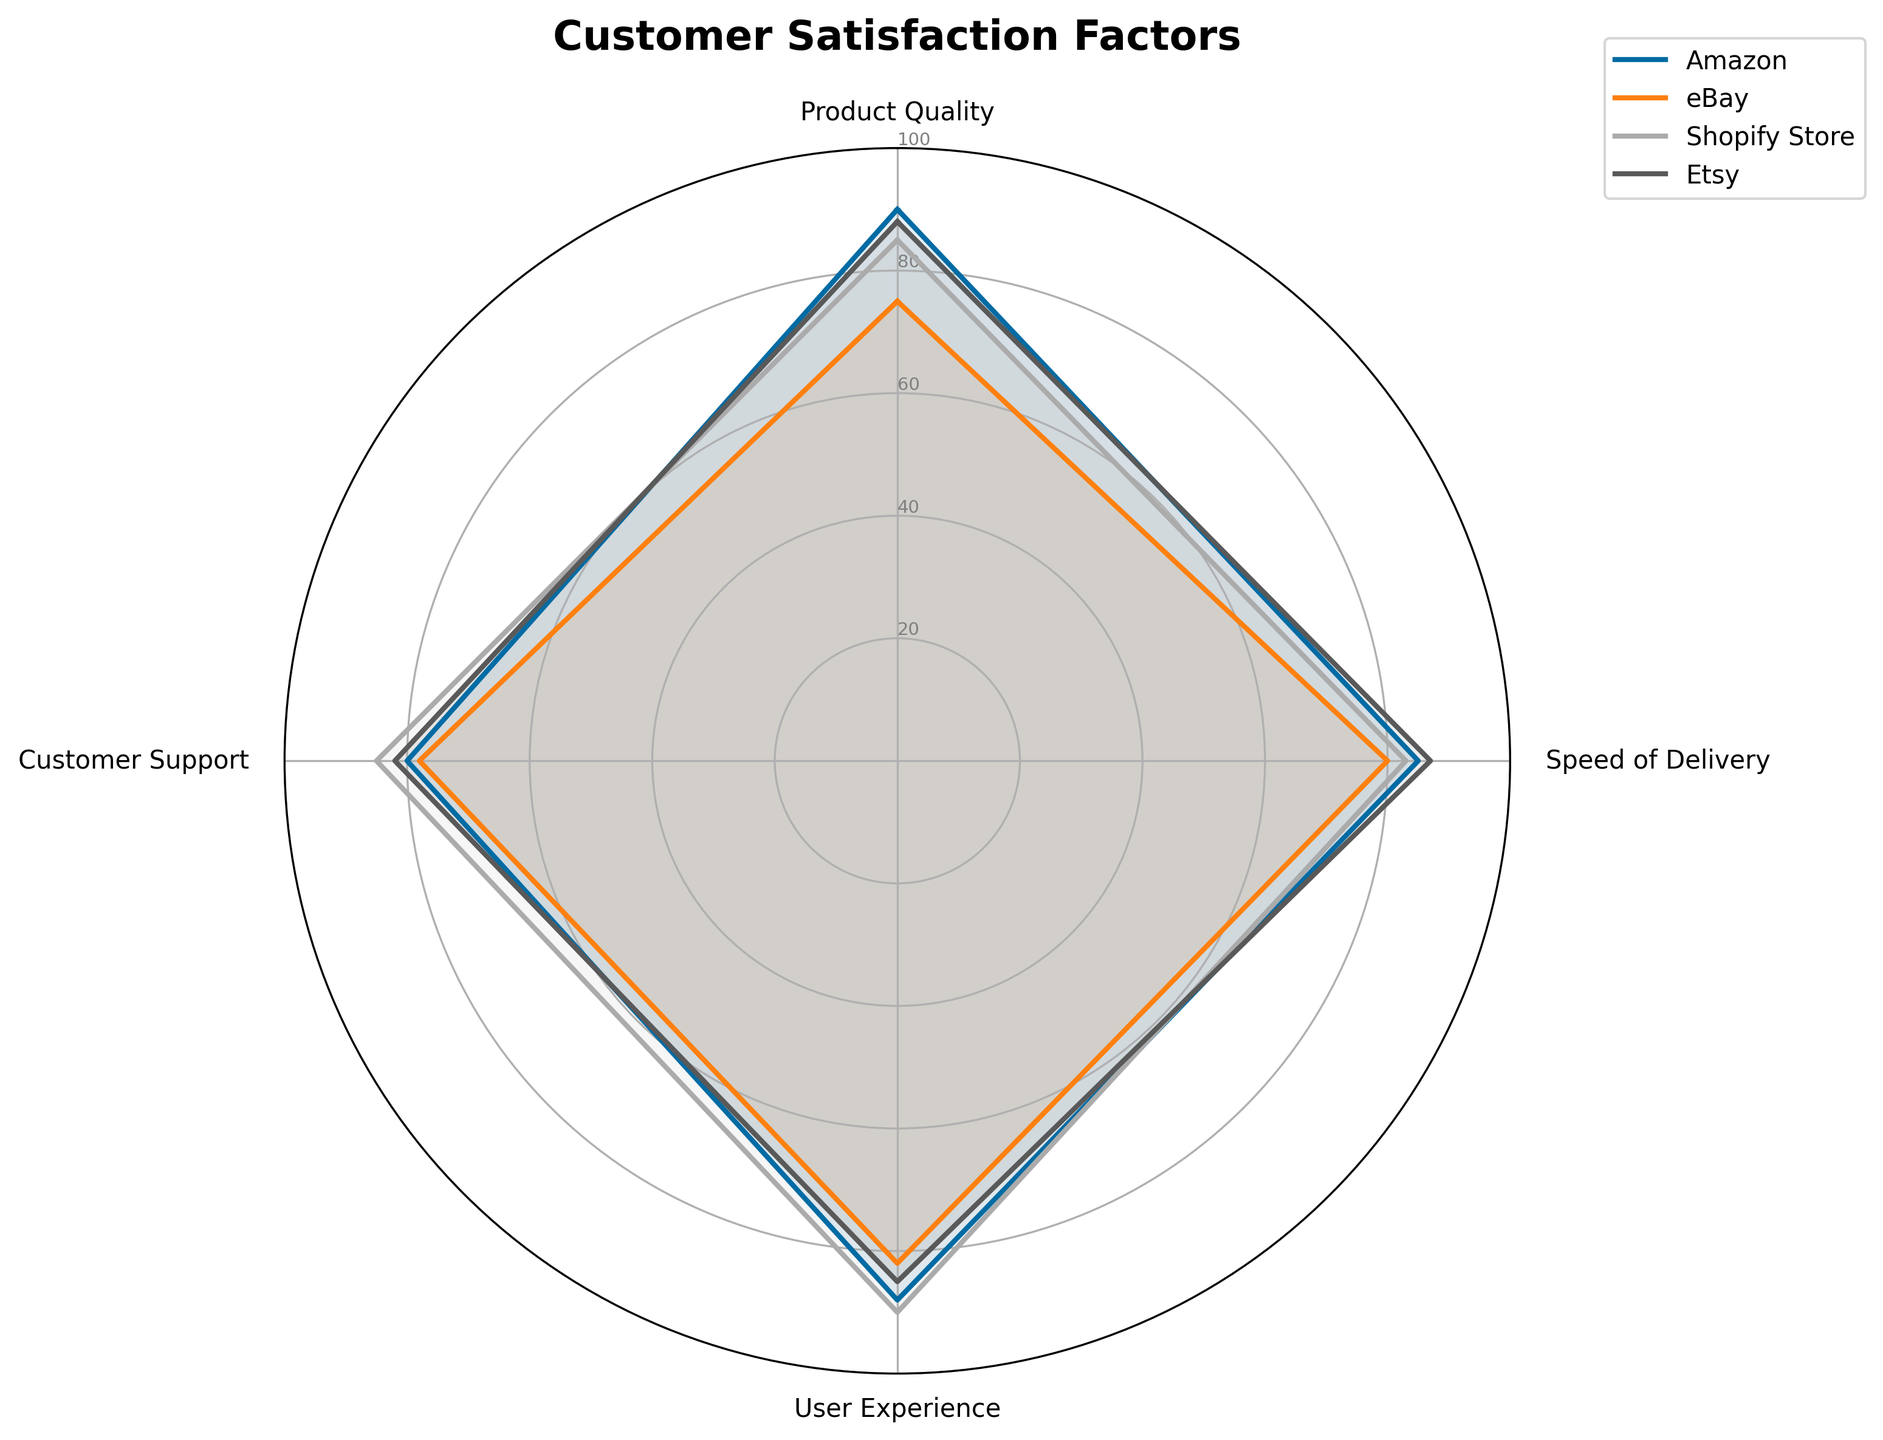What is the title of the figure? The title is usually placed at the top of the chart. In this case, the title is "Customer Satisfaction Factors".
Answer: Customer Satisfaction Factors Which category has the highest score for Product Quality? By looking at the radar chart, identify the values for Product Quality for each category and see which one is the highest. Amazon scores 90, eBay scores 75, Shopify Store scores 85, and Etsy scores 88.
Answer: Amazon What is the average score of User Experience across all categories? Sum up the User Experience scores of all categories and divide by the number of categories. (88 + 82 + 90 + 85) / 4 = 345 / 4 = 86.25
Answer: 86.25 Which category shows the weakest performance in Speed of Delivery? Identify the Speed of Delivery values for each category and find the lowest one: Amazon (85), eBay (80), Shopify Store (83), Etsy (87).
Answer: eBay Between Amazon and Shopify Store, which category has better Customer Support? Compare the Customer Support values of Amazon (80) and Shopify Store (85), and note which one is higher.
Answer: Shopify Store What is the difference in Product Quality scores between Shopify Store and eBay? Subtract the Product Quality score of eBay from that of Shopify Store: 85 - 75 = 10.
Answer: 10 Which category has the most consistent performance across all factors? Analyze the radar chart to identify which category's plot line is more evenly spread and balanced across all factors without large fluctuations.
Answer: Etsy What is the combined score of Speed of Delivery and User Experience for Etsy? Add the Speed of Delivery (87) and User Experience (85) scores for Etsy: 87 + 85 = 172.
Answer: 172 Which two categories have the closest scores in Customer Support? Compare the Customer Support scores and find the smallest difference: Amazon (80), eBay (78), Shopify Store (85), Etsy (82). The smallest difference is between Amazon and Etsy (80 - 82 = 2).
Answer: Amazon and Etsy How does Shopify Store's User Experience compare to Amazon's? Compare the User Experience scores: Shopify Store (90) and Amazon (88). Shopify Store's score is higher.
Answer: Shopify Store 